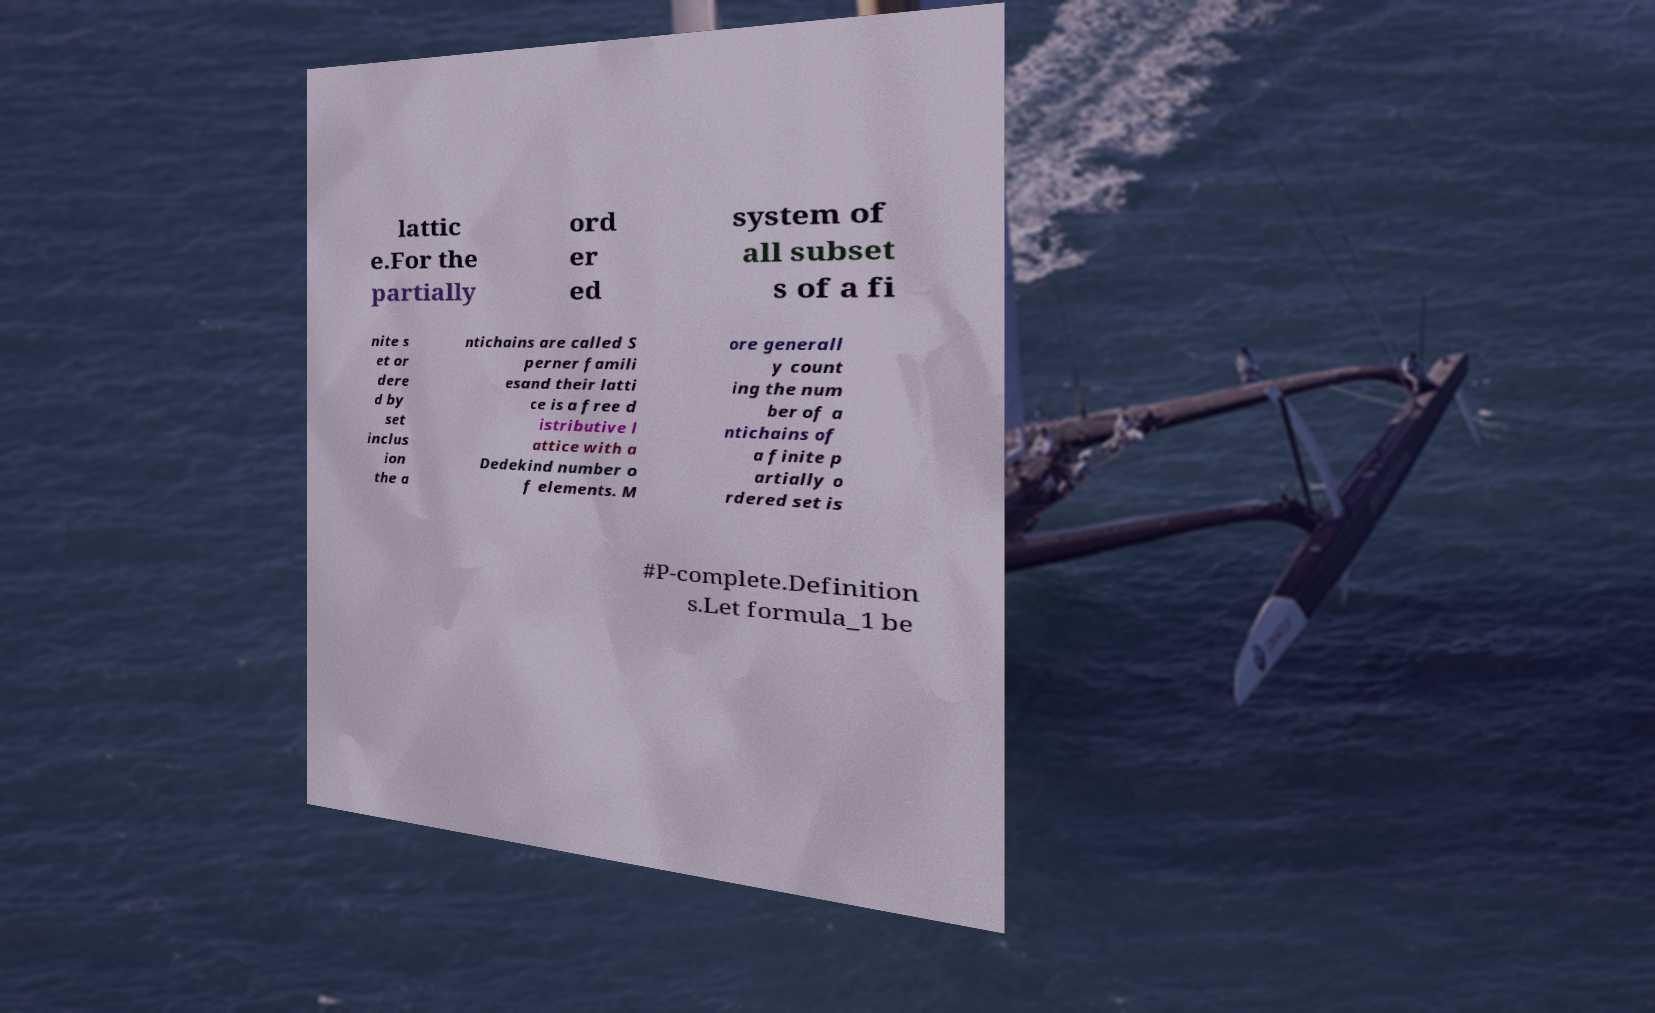There's text embedded in this image that I need extracted. Can you transcribe it verbatim? lattic e.For the partially ord er ed system of all subset s of a fi nite s et or dere d by set inclus ion the a ntichains are called S perner famili esand their latti ce is a free d istributive l attice with a Dedekind number o f elements. M ore generall y count ing the num ber of a ntichains of a finite p artially o rdered set is #P-complete.Definition s.Let formula_1 be 